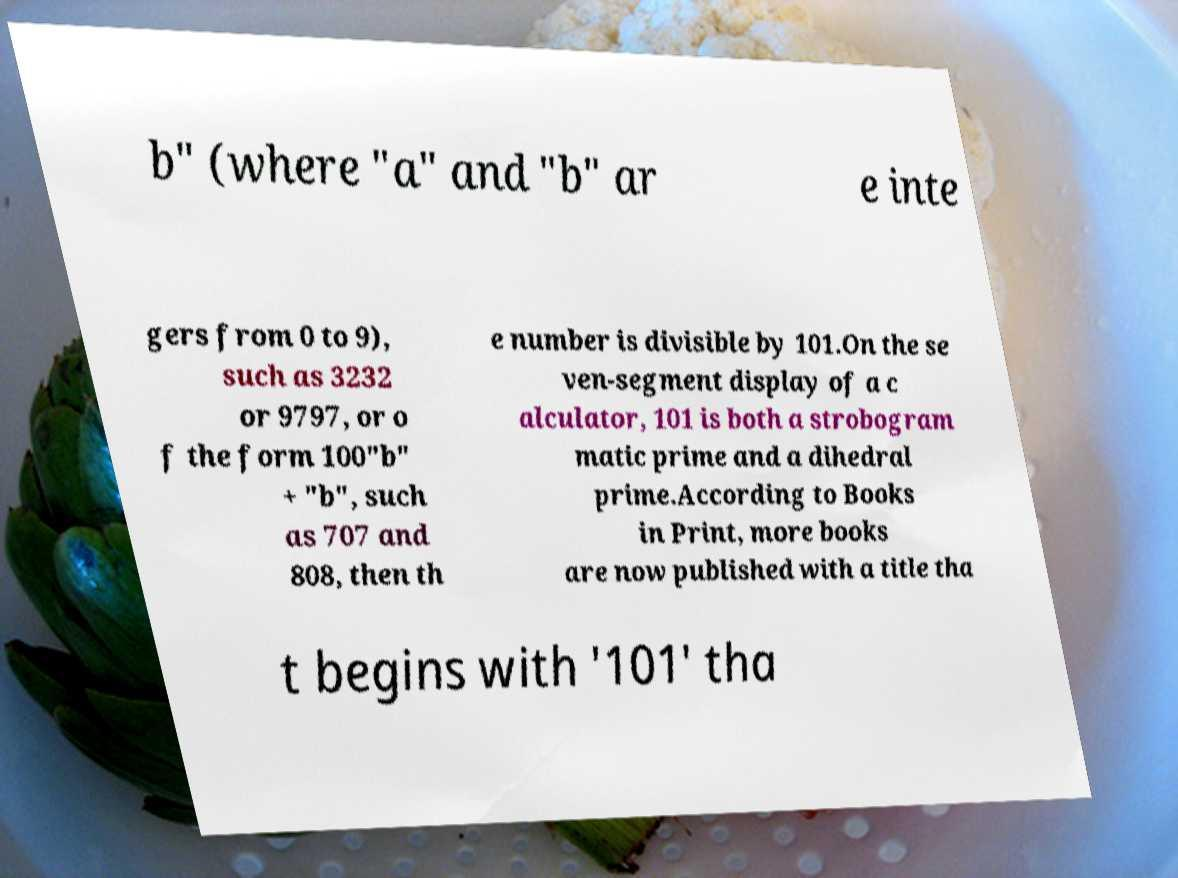For documentation purposes, I need the text within this image transcribed. Could you provide that? b" (where "a" and "b" ar e inte gers from 0 to 9), such as 3232 or 9797, or o f the form 100"b" + "b", such as 707 and 808, then th e number is divisible by 101.On the se ven-segment display of a c alculator, 101 is both a strobogram matic prime and a dihedral prime.According to Books in Print, more books are now published with a title tha t begins with '101' tha 